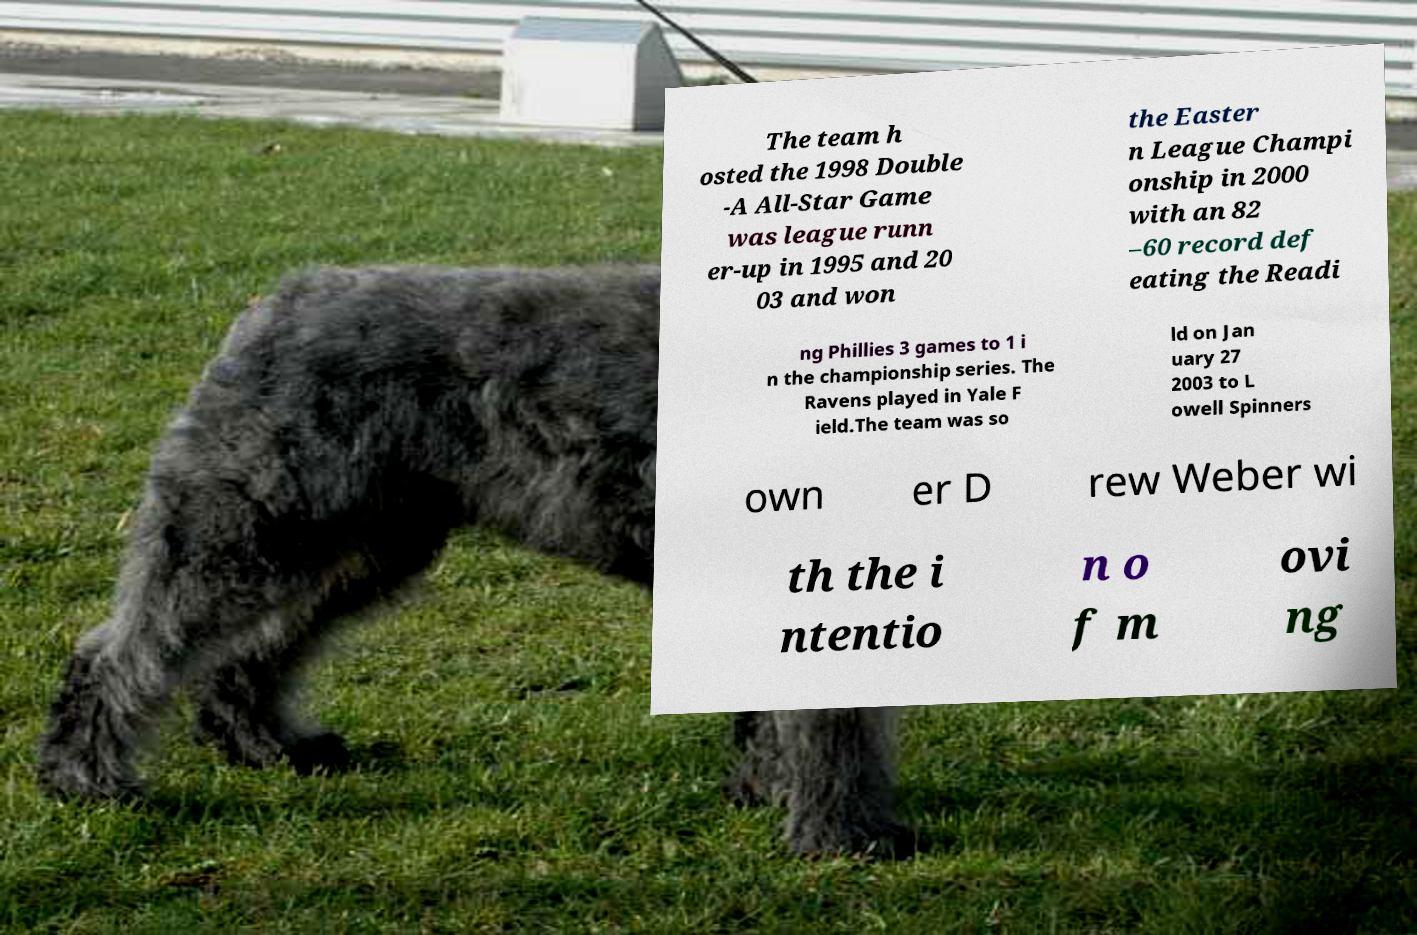Could you assist in decoding the text presented in this image and type it out clearly? The team h osted the 1998 Double -A All-Star Game was league runn er-up in 1995 and 20 03 and won the Easter n League Champi onship in 2000 with an 82 –60 record def eating the Readi ng Phillies 3 games to 1 i n the championship series. The Ravens played in Yale F ield.The team was so ld on Jan uary 27 2003 to L owell Spinners own er D rew Weber wi th the i ntentio n o f m ovi ng 